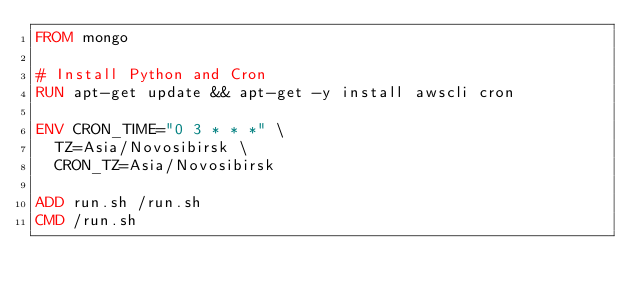<code> <loc_0><loc_0><loc_500><loc_500><_Dockerfile_>FROM mongo

# Install Python and Cron
RUN apt-get update && apt-get -y install awscli cron

ENV CRON_TIME="0 3 * * *" \
  TZ=Asia/Novosibirsk \
  CRON_TZ=Asia/Novosibirsk

ADD run.sh /run.sh
CMD /run.sh
</code> 